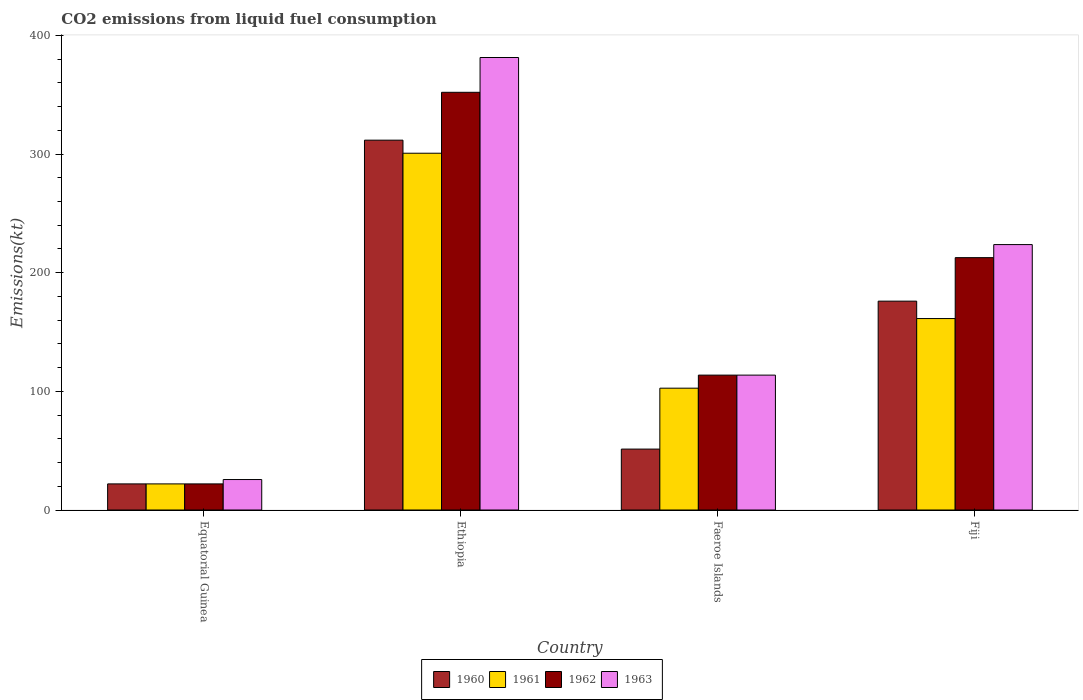How many different coloured bars are there?
Keep it short and to the point. 4. Are the number of bars per tick equal to the number of legend labels?
Offer a very short reply. Yes. Are the number of bars on each tick of the X-axis equal?
Ensure brevity in your answer.  Yes. How many bars are there on the 2nd tick from the right?
Offer a terse response. 4. What is the label of the 4th group of bars from the left?
Your response must be concise. Fiji. In how many cases, is the number of bars for a given country not equal to the number of legend labels?
Your response must be concise. 0. What is the amount of CO2 emitted in 1961 in Ethiopia?
Your answer should be very brief. 300.69. Across all countries, what is the maximum amount of CO2 emitted in 1962?
Offer a terse response. 352.03. Across all countries, what is the minimum amount of CO2 emitted in 1961?
Your answer should be compact. 22. In which country was the amount of CO2 emitted in 1961 maximum?
Offer a terse response. Ethiopia. In which country was the amount of CO2 emitted in 1962 minimum?
Provide a succinct answer. Equatorial Guinea. What is the total amount of CO2 emitted in 1961 in the graph?
Provide a succinct answer. 586.72. What is the difference between the amount of CO2 emitted in 1960 in Ethiopia and that in Fiji?
Your answer should be very brief. 135.68. What is the difference between the amount of CO2 emitted in 1963 in Equatorial Guinea and the amount of CO2 emitted in 1961 in Fiji?
Keep it short and to the point. -135.68. What is the average amount of CO2 emitted in 1961 per country?
Your answer should be compact. 146.68. What is the difference between the amount of CO2 emitted of/in 1962 and amount of CO2 emitted of/in 1963 in Equatorial Guinea?
Provide a succinct answer. -3.67. What is the ratio of the amount of CO2 emitted in 1961 in Equatorial Guinea to that in Faeroe Islands?
Ensure brevity in your answer.  0.21. Is the difference between the amount of CO2 emitted in 1962 in Equatorial Guinea and Faeroe Islands greater than the difference between the amount of CO2 emitted in 1963 in Equatorial Guinea and Faeroe Islands?
Offer a terse response. No. What is the difference between the highest and the second highest amount of CO2 emitted in 1963?
Offer a terse response. -267.69. What is the difference between the highest and the lowest amount of CO2 emitted in 1963?
Give a very brief answer. 355.7. Is the sum of the amount of CO2 emitted in 1960 in Faeroe Islands and Fiji greater than the maximum amount of CO2 emitted in 1961 across all countries?
Your answer should be compact. No. What does the 2nd bar from the left in Fiji represents?
Your answer should be very brief. 1961. What does the 4th bar from the right in Fiji represents?
Your response must be concise. 1960. Are all the bars in the graph horizontal?
Provide a succinct answer. No. How many countries are there in the graph?
Offer a very short reply. 4. Does the graph contain grids?
Your answer should be compact. No. Where does the legend appear in the graph?
Your answer should be very brief. Bottom center. How many legend labels are there?
Provide a succinct answer. 4. How are the legend labels stacked?
Provide a succinct answer. Horizontal. What is the title of the graph?
Provide a short and direct response. CO2 emissions from liquid fuel consumption. What is the label or title of the X-axis?
Give a very brief answer. Country. What is the label or title of the Y-axis?
Make the answer very short. Emissions(kt). What is the Emissions(kt) in 1960 in Equatorial Guinea?
Make the answer very short. 22. What is the Emissions(kt) in 1961 in Equatorial Guinea?
Offer a very short reply. 22. What is the Emissions(kt) in 1962 in Equatorial Guinea?
Provide a succinct answer. 22. What is the Emissions(kt) of 1963 in Equatorial Guinea?
Ensure brevity in your answer.  25.67. What is the Emissions(kt) in 1960 in Ethiopia?
Make the answer very short. 311.69. What is the Emissions(kt) in 1961 in Ethiopia?
Your response must be concise. 300.69. What is the Emissions(kt) in 1962 in Ethiopia?
Provide a short and direct response. 352.03. What is the Emissions(kt) in 1963 in Ethiopia?
Provide a succinct answer. 381.37. What is the Emissions(kt) of 1960 in Faeroe Islands?
Provide a short and direct response. 51.34. What is the Emissions(kt) in 1961 in Faeroe Islands?
Make the answer very short. 102.68. What is the Emissions(kt) in 1962 in Faeroe Islands?
Provide a short and direct response. 113.68. What is the Emissions(kt) of 1963 in Faeroe Islands?
Make the answer very short. 113.68. What is the Emissions(kt) in 1960 in Fiji?
Give a very brief answer. 176.02. What is the Emissions(kt) in 1961 in Fiji?
Your answer should be compact. 161.35. What is the Emissions(kt) of 1962 in Fiji?
Your answer should be compact. 212.69. What is the Emissions(kt) in 1963 in Fiji?
Offer a terse response. 223.69. Across all countries, what is the maximum Emissions(kt) in 1960?
Provide a short and direct response. 311.69. Across all countries, what is the maximum Emissions(kt) in 1961?
Provide a succinct answer. 300.69. Across all countries, what is the maximum Emissions(kt) of 1962?
Offer a terse response. 352.03. Across all countries, what is the maximum Emissions(kt) of 1963?
Provide a succinct answer. 381.37. Across all countries, what is the minimum Emissions(kt) of 1960?
Provide a short and direct response. 22. Across all countries, what is the minimum Emissions(kt) in 1961?
Provide a succinct answer. 22. Across all countries, what is the minimum Emissions(kt) in 1962?
Your response must be concise. 22. Across all countries, what is the minimum Emissions(kt) in 1963?
Your answer should be compact. 25.67. What is the total Emissions(kt) in 1960 in the graph?
Provide a short and direct response. 561.05. What is the total Emissions(kt) of 1961 in the graph?
Provide a succinct answer. 586.72. What is the total Emissions(kt) of 1962 in the graph?
Make the answer very short. 700.4. What is the total Emissions(kt) of 1963 in the graph?
Give a very brief answer. 744.4. What is the difference between the Emissions(kt) of 1960 in Equatorial Guinea and that in Ethiopia?
Your answer should be very brief. -289.69. What is the difference between the Emissions(kt) of 1961 in Equatorial Guinea and that in Ethiopia?
Give a very brief answer. -278.69. What is the difference between the Emissions(kt) of 1962 in Equatorial Guinea and that in Ethiopia?
Give a very brief answer. -330.03. What is the difference between the Emissions(kt) of 1963 in Equatorial Guinea and that in Ethiopia?
Your answer should be compact. -355.7. What is the difference between the Emissions(kt) in 1960 in Equatorial Guinea and that in Faeroe Islands?
Your answer should be compact. -29.34. What is the difference between the Emissions(kt) of 1961 in Equatorial Guinea and that in Faeroe Islands?
Keep it short and to the point. -80.67. What is the difference between the Emissions(kt) in 1962 in Equatorial Guinea and that in Faeroe Islands?
Offer a terse response. -91.67. What is the difference between the Emissions(kt) in 1963 in Equatorial Guinea and that in Faeroe Islands?
Provide a succinct answer. -88.01. What is the difference between the Emissions(kt) of 1960 in Equatorial Guinea and that in Fiji?
Keep it short and to the point. -154.01. What is the difference between the Emissions(kt) in 1961 in Equatorial Guinea and that in Fiji?
Offer a terse response. -139.35. What is the difference between the Emissions(kt) of 1962 in Equatorial Guinea and that in Fiji?
Ensure brevity in your answer.  -190.68. What is the difference between the Emissions(kt) in 1963 in Equatorial Guinea and that in Fiji?
Your response must be concise. -198.02. What is the difference between the Emissions(kt) in 1960 in Ethiopia and that in Faeroe Islands?
Ensure brevity in your answer.  260.36. What is the difference between the Emissions(kt) of 1961 in Ethiopia and that in Faeroe Islands?
Your answer should be compact. 198.02. What is the difference between the Emissions(kt) of 1962 in Ethiopia and that in Faeroe Islands?
Keep it short and to the point. 238.35. What is the difference between the Emissions(kt) in 1963 in Ethiopia and that in Faeroe Islands?
Make the answer very short. 267.69. What is the difference between the Emissions(kt) in 1960 in Ethiopia and that in Fiji?
Your response must be concise. 135.68. What is the difference between the Emissions(kt) in 1961 in Ethiopia and that in Fiji?
Your answer should be compact. 139.35. What is the difference between the Emissions(kt) in 1962 in Ethiopia and that in Fiji?
Ensure brevity in your answer.  139.35. What is the difference between the Emissions(kt) in 1963 in Ethiopia and that in Fiji?
Offer a very short reply. 157.68. What is the difference between the Emissions(kt) in 1960 in Faeroe Islands and that in Fiji?
Your answer should be compact. -124.68. What is the difference between the Emissions(kt) in 1961 in Faeroe Islands and that in Fiji?
Your answer should be compact. -58.67. What is the difference between the Emissions(kt) of 1962 in Faeroe Islands and that in Fiji?
Offer a terse response. -99.01. What is the difference between the Emissions(kt) of 1963 in Faeroe Islands and that in Fiji?
Give a very brief answer. -110.01. What is the difference between the Emissions(kt) in 1960 in Equatorial Guinea and the Emissions(kt) in 1961 in Ethiopia?
Keep it short and to the point. -278.69. What is the difference between the Emissions(kt) in 1960 in Equatorial Guinea and the Emissions(kt) in 1962 in Ethiopia?
Your response must be concise. -330.03. What is the difference between the Emissions(kt) in 1960 in Equatorial Guinea and the Emissions(kt) in 1963 in Ethiopia?
Give a very brief answer. -359.37. What is the difference between the Emissions(kt) of 1961 in Equatorial Guinea and the Emissions(kt) of 1962 in Ethiopia?
Provide a short and direct response. -330.03. What is the difference between the Emissions(kt) in 1961 in Equatorial Guinea and the Emissions(kt) in 1963 in Ethiopia?
Make the answer very short. -359.37. What is the difference between the Emissions(kt) of 1962 in Equatorial Guinea and the Emissions(kt) of 1963 in Ethiopia?
Your answer should be compact. -359.37. What is the difference between the Emissions(kt) in 1960 in Equatorial Guinea and the Emissions(kt) in 1961 in Faeroe Islands?
Offer a very short reply. -80.67. What is the difference between the Emissions(kt) of 1960 in Equatorial Guinea and the Emissions(kt) of 1962 in Faeroe Islands?
Offer a terse response. -91.67. What is the difference between the Emissions(kt) in 1960 in Equatorial Guinea and the Emissions(kt) in 1963 in Faeroe Islands?
Your response must be concise. -91.67. What is the difference between the Emissions(kt) in 1961 in Equatorial Guinea and the Emissions(kt) in 1962 in Faeroe Islands?
Provide a succinct answer. -91.67. What is the difference between the Emissions(kt) of 1961 in Equatorial Guinea and the Emissions(kt) of 1963 in Faeroe Islands?
Make the answer very short. -91.67. What is the difference between the Emissions(kt) in 1962 in Equatorial Guinea and the Emissions(kt) in 1963 in Faeroe Islands?
Give a very brief answer. -91.67. What is the difference between the Emissions(kt) of 1960 in Equatorial Guinea and the Emissions(kt) of 1961 in Fiji?
Your answer should be very brief. -139.35. What is the difference between the Emissions(kt) in 1960 in Equatorial Guinea and the Emissions(kt) in 1962 in Fiji?
Offer a terse response. -190.68. What is the difference between the Emissions(kt) of 1960 in Equatorial Guinea and the Emissions(kt) of 1963 in Fiji?
Your answer should be very brief. -201.69. What is the difference between the Emissions(kt) of 1961 in Equatorial Guinea and the Emissions(kt) of 1962 in Fiji?
Your answer should be compact. -190.68. What is the difference between the Emissions(kt) in 1961 in Equatorial Guinea and the Emissions(kt) in 1963 in Fiji?
Offer a very short reply. -201.69. What is the difference between the Emissions(kt) of 1962 in Equatorial Guinea and the Emissions(kt) of 1963 in Fiji?
Make the answer very short. -201.69. What is the difference between the Emissions(kt) of 1960 in Ethiopia and the Emissions(kt) of 1961 in Faeroe Islands?
Provide a short and direct response. 209.02. What is the difference between the Emissions(kt) of 1960 in Ethiopia and the Emissions(kt) of 1962 in Faeroe Islands?
Your answer should be compact. 198.02. What is the difference between the Emissions(kt) of 1960 in Ethiopia and the Emissions(kt) of 1963 in Faeroe Islands?
Provide a short and direct response. 198.02. What is the difference between the Emissions(kt) of 1961 in Ethiopia and the Emissions(kt) of 1962 in Faeroe Islands?
Ensure brevity in your answer.  187.02. What is the difference between the Emissions(kt) in 1961 in Ethiopia and the Emissions(kt) in 1963 in Faeroe Islands?
Offer a terse response. 187.02. What is the difference between the Emissions(kt) of 1962 in Ethiopia and the Emissions(kt) of 1963 in Faeroe Islands?
Provide a short and direct response. 238.35. What is the difference between the Emissions(kt) of 1960 in Ethiopia and the Emissions(kt) of 1961 in Fiji?
Offer a terse response. 150.35. What is the difference between the Emissions(kt) of 1960 in Ethiopia and the Emissions(kt) of 1962 in Fiji?
Give a very brief answer. 99.01. What is the difference between the Emissions(kt) in 1960 in Ethiopia and the Emissions(kt) in 1963 in Fiji?
Give a very brief answer. 88.01. What is the difference between the Emissions(kt) of 1961 in Ethiopia and the Emissions(kt) of 1962 in Fiji?
Give a very brief answer. 88.01. What is the difference between the Emissions(kt) in 1961 in Ethiopia and the Emissions(kt) in 1963 in Fiji?
Give a very brief answer. 77.01. What is the difference between the Emissions(kt) in 1962 in Ethiopia and the Emissions(kt) in 1963 in Fiji?
Your answer should be compact. 128.34. What is the difference between the Emissions(kt) in 1960 in Faeroe Islands and the Emissions(kt) in 1961 in Fiji?
Keep it short and to the point. -110.01. What is the difference between the Emissions(kt) in 1960 in Faeroe Islands and the Emissions(kt) in 1962 in Fiji?
Your answer should be very brief. -161.35. What is the difference between the Emissions(kt) in 1960 in Faeroe Islands and the Emissions(kt) in 1963 in Fiji?
Provide a succinct answer. -172.35. What is the difference between the Emissions(kt) in 1961 in Faeroe Islands and the Emissions(kt) in 1962 in Fiji?
Provide a short and direct response. -110.01. What is the difference between the Emissions(kt) in 1961 in Faeroe Islands and the Emissions(kt) in 1963 in Fiji?
Offer a very short reply. -121.01. What is the difference between the Emissions(kt) of 1962 in Faeroe Islands and the Emissions(kt) of 1963 in Fiji?
Your response must be concise. -110.01. What is the average Emissions(kt) of 1960 per country?
Give a very brief answer. 140.26. What is the average Emissions(kt) in 1961 per country?
Provide a succinct answer. 146.68. What is the average Emissions(kt) in 1962 per country?
Provide a succinct answer. 175.1. What is the average Emissions(kt) of 1963 per country?
Your answer should be compact. 186.1. What is the difference between the Emissions(kt) of 1960 and Emissions(kt) of 1963 in Equatorial Guinea?
Your answer should be compact. -3.67. What is the difference between the Emissions(kt) in 1961 and Emissions(kt) in 1963 in Equatorial Guinea?
Offer a very short reply. -3.67. What is the difference between the Emissions(kt) in 1962 and Emissions(kt) in 1963 in Equatorial Guinea?
Ensure brevity in your answer.  -3.67. What is the difference between the Emissions(kt) in 1960 and Emissions(kt) in 1961 in Ethiopia?
Give a very brief answer. 11. What is the difference between the Emissions(kt) of 1960 and Emissions(kt) of 1962 in Ethiopia?
Your response must be concise. -40.34. What is the difference between the Emissions(kt) in 1960 and Emissions(kt) in 1963 in Ethiopia?
Make the answer very short. -69.67. What is the difference between the Emissions(kt) in 1961 and Emissions(kt) in 1962 in Ethiopia?
Give a very brief answer. -51.34. What is the difference between the Emissions(kt) in 1961 and Emissions(kt) in 1963 in Ethiopia?
Provide a succinct answer. -80.67. What is the difference between the Emissions(kt) of 1962 and Emissions(kt) of 1963 in Ethiopia?
Give a very brief answer. -29.34. What is the difference between the Emissions(kt) of 1960 and Emissions(kt) of 1961 in Faeroe Islands?
Give a very brief answer. -51.34. What is the difference between the Emissions(kt) in 1960 and Emissions(kt) in 1962 in Faeroe Islands?
Give a very brief answer. -62.34. What is the difference between the Emissions(kt) in 1960 and Emissions(kt) in 1963 in Faeroe Islands?
Your answer should be compact. -62.34. What is the difference between the Emissions(kt) in 1961 and Emissions(kt) in 1962 in Faeroe Islands?
Ensure brevity in your answer.  -11. What is the difference between the Emissions(kt) in 1961 and Emissions(kt) in 1963 in Faeroe Islands?
Give a very brief answer. -11. What is the difference between the Emissions(kt) of 1960 and Emissions(kt) of 1961 in Fiji?
Ensure brevity in your answer.  14.67. What is the difference between the Emissions(kt) of 1960 and Emissions(kt) of 1962 in Fiji?
Keep it short and to the point. -36.67. What is the difference between the Emissions(kt) in 1960 and Emissions(kt) in 1963 in Fiji?
Ensure brevity in your answer.  -47.67. What is the difference between the Emissions(kt) in 1961 and Emissions(kt) in 1962 in Fiji?
Offer a terse response. -51.34. What is the difference between the Emissions(kt) in 1961 and Emissions(kt) in 1963 in Fiji?
Ensure brevity in your answer.  -62.34. What is the difference between the Emissions(kt) of 1962 and Emissions(kt) of 1963 in Fiji?
Your answer should be compact. -11. What is the ratio of the Emissions(kt) in 1960 in Equatorial Guinea to that in Ethiopia?
Your answer should be compact. 0.07. What is the ratio of the Emissions(kt) of 1961 in Equatorial Guinea to that in Ethiopia?
Offer a terse response. 0.07. What is the ratio of the Emissions(kt) of 1962 in Equatorial Guinea to that in Ethiopia?
Ensure brevity in your answer.  0.06. What is the ratio of the Emissions(kt) of 1963 in Equatorial Guinea to that in Ethiopia?
Give a very brief answer. 0.07. What is the ratio of the Emissions(kt) of 1960 in Equatorial Guinea to that in Faeroe Islands?
Make the answer very short. 0.43. What is the ratio of the Emissions(kt) in 1961 in Equatorial Guinea to that in Faeroe Islands?
Offer a terse response. 0.21. What is the ratio of the Emissions(kt) of 1962 in Equatorial Guinea to that in Faeroe Islands?
Ensure brevity in your answer.  0.19. What is the ratio of the Emissions(kt) in 1963 in Equatorial Guinea to that in Faeroe Islands?
Make the answer very short. 0.23. What is the ratio of the Emissions(kt) of 1960 in Equatorial Guinea to that in Fiji?
Your response must be concise. 0.12. What is the ratio of the Emissions(kt) in 1961 in Equatorial Guinea to that in Fiji?
Provide a short and direct response. 0.14. What is the ratio of the Emissions(kt) of 1962 in Equatorial Guinea to that in Fiji?
Your answer should be compact. 0.1. What is the ratio of the Emissions(kt) of 1963 in Equatorial Guinea to that in Fiji?
Ensure brevity in your answer.  0.11. What is the ratio of the Emissions(kt) in 1960 in Ethiopia to that in Faeroe Islands?
Offer a very short reply. 6.07. What is the ratio of the Emissions(kt) of 1961 in Ethiopia to that in Faeroe Islands?
Keep it short and to the point. 2.93. What is the ratio of the Emissions(kt) in 1962 in Ethiopia to that in Faeroe Islands?
Keep it short and to the point. 3.1. What is the ratio of the Emissions(kt) in 1963 in Ethiopia to that in Faeroe Islands?
Provide a short and direct response. 3.35. What is the ratio of the Emissions(kt) in 1960 in Ethiopia to that in Fiji?
Your response must be concise. 1.77. What is the ratio of the Emissions(kt) in 1961 in Ethiopia to that in Fiji?
Keep it short and to the point. 1.86. What is the ratio of the Emissions(kt) of 1962 in Ethiopia to that in Fiji?
Offer a terse response. 1.66. What is the ratio of the Emissions(kt) in 1963 in Ethiopia to that in Fiji?
Provide a short and direct response. 1.7. What is the ratio of the Emissions(kt) of 1960 in Faeroe Islands to that in Fiji?
Give a very brief answer. 0.29. What is the ratio of the Emissions(kt) in 1961 in Faeroe Islands to that in Fiji?
Keep it short and to the point. 0.64. What is the ratio of the Emissions(kt) in 1962 in Faeroe Islands to that in Fiji?
Your answer should be very brief. 0.53. What is the ratio of the Emissions(kt) in 1963 in Faeroe Islands to that in Fiji?
Provide a short and direct response. 0.51. What is the difference between the highest and the second highest Emissions(kt) in 1960?
Ensure brevity in your answer.  135.68. What is the difference between the highest and the second highest Emissions(kt) of 1961?
Your answer should be very brief. 139.35. What is the difference between the highest and the second highest Emissions(kt) in 1962?
Make the answer very short. 139.35. What is the difference between the highest and the second highest Emissions(kt) of 1963?
Give a very brief answer. 157.68. What is the difference between the highest and the lowest Emissions(kt) of 1960?
Your answer should be very brief. 289.69. What is the difference between the highest and the lowest Emissions(kt) in 1961?
Your response must be concise. 278.69. What is the difference between the highest and the lowest Emissions(kt) of 1962?
Offer a very short reply. 330.03. What is the difference between the highest and the lowest Emissions(kt) in 1963?
Ensure brevity in your answer.  355.7. 